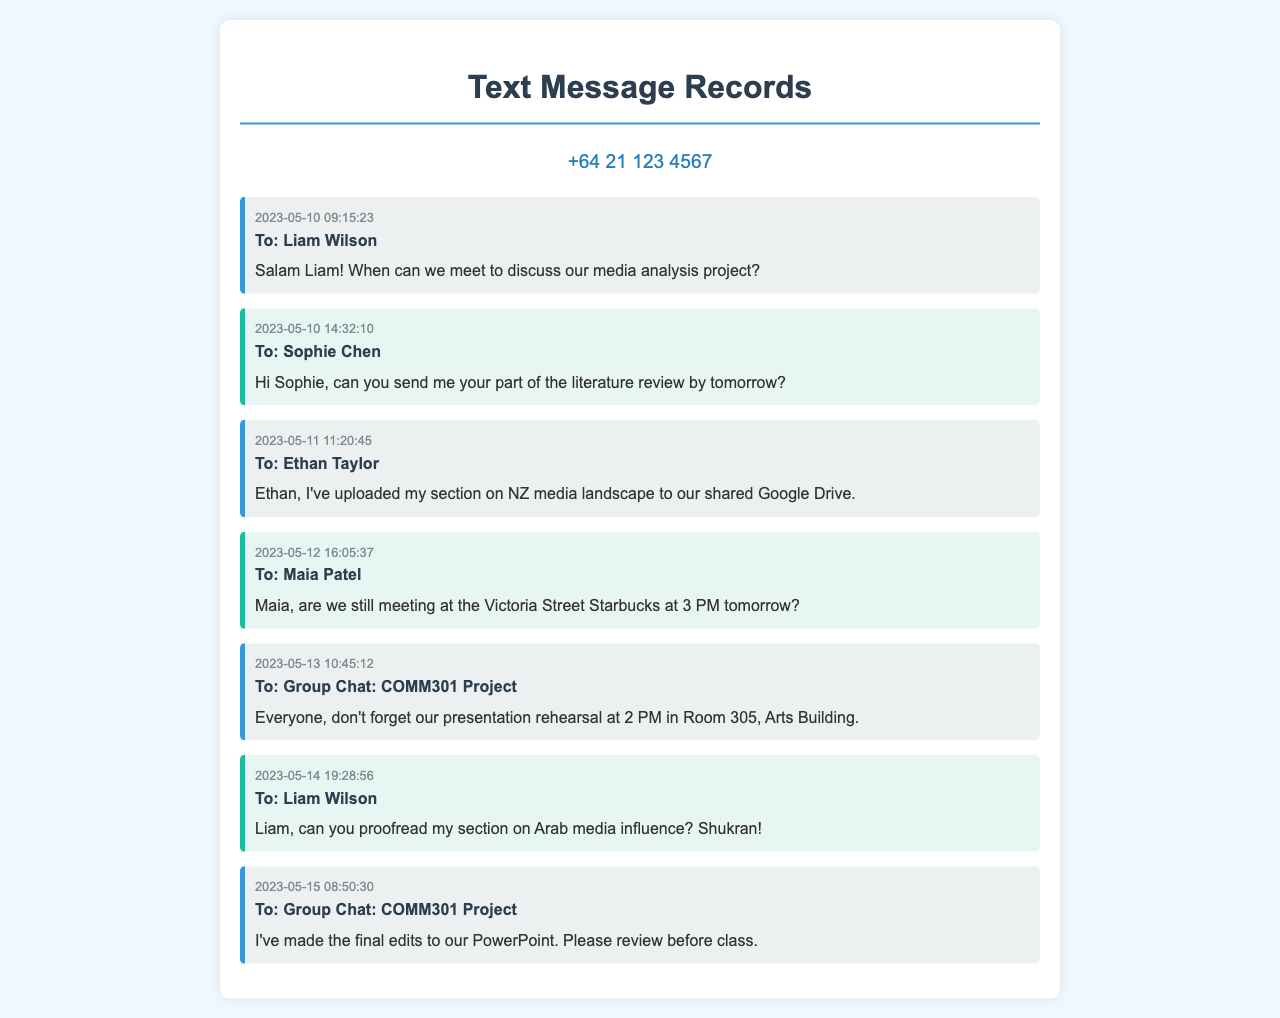What is the first message date? The first message in the records is dated 2023-05-10.
Answer: 2023-05-10 Who is the recipient of the message sent on 2023-05-12? The message sent on 2023-05-12 is addressed to Maia Patel.
Answer: Maia Patel What time is the presentation rehearsal scheduled? The presentation rehearsal is scheduled for 2 PM.
Answer: 2 PM Which project is being coordinated in the group chat? The group chat coordinates the COMM301 Project.
Answer: COMM301 Project How many messages are addressed to the group chat? There are two messages addressed to the group chat, according to the document.
Answer: 2 What document section did Ethan Taylor upload? Ethan uploaded his section on NZ media landscape.
Answer: NZ media landscape What did Liam Wilson request on 2023-05-14? Liam requested to proofread the section on Arab media influence.
Answer: proofread my section on Arab media influence What did the sender remind the group about on 2023-05-13? The sender reminded everyone about the presentation rehearsal at 2 PM.
Answer: presentation rehearsal at 2 PM What is the content type of the records? The document contains itemized text messages.
Answer: text messages 